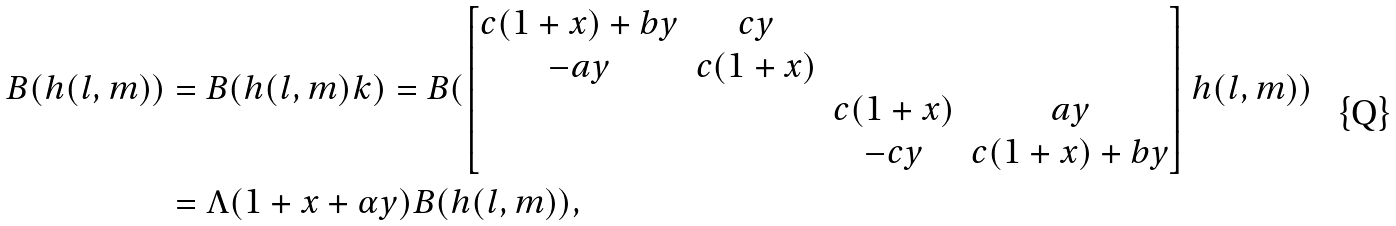<formula> <loc_0><loc_0><loc_500><loc_500>B ( h ( l , m ) ) & = B ( h ( l , m ) k ) = B ( \begin{bmatrix} c ( 1 + x ) + b y & c y & & \\ - a y & c ( 1 + x ) & & \\ & & c ( 1 + x ) & a y \\ & & - c y & c ( 1 + x ) + b y \end{bmatrix} h ( l , m ) ) \\ & = \Lambda ( 1 + x + \alpha y ) B ( h ( l , m ) ) ,</formula> 